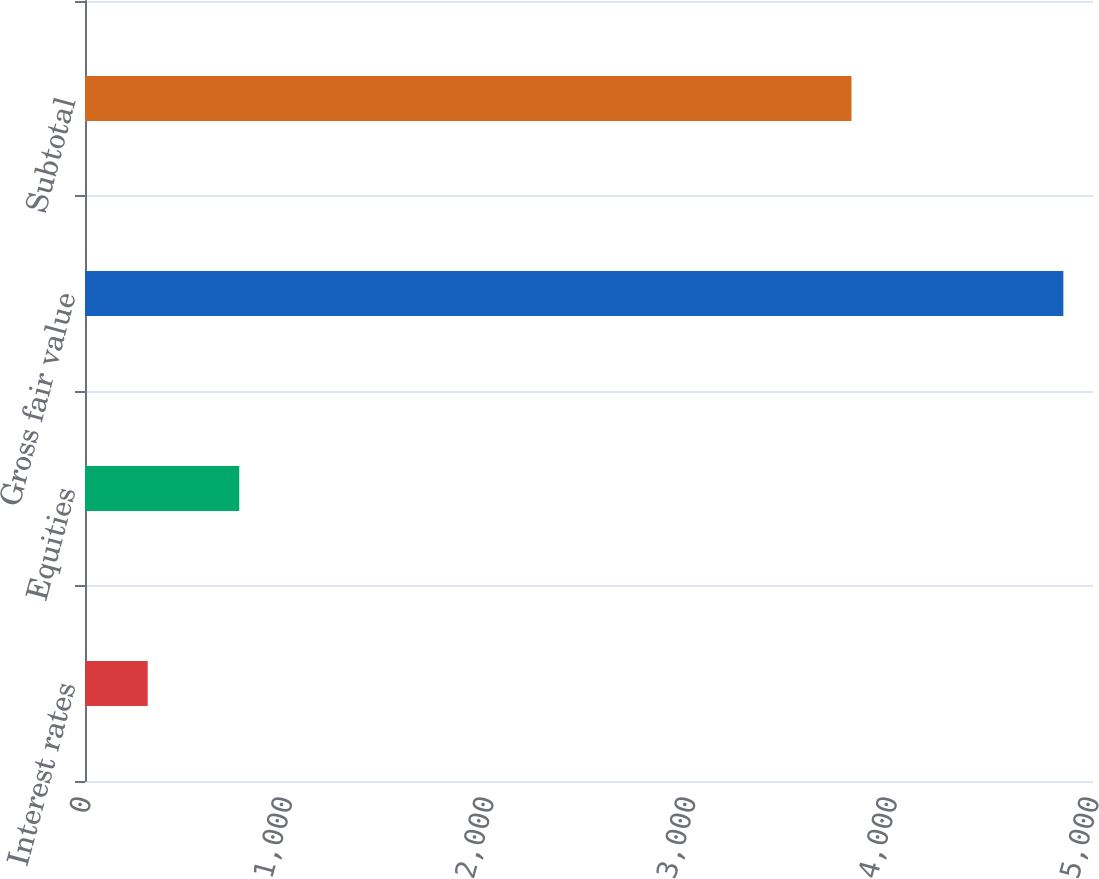Convert chart to OTSL. <chart><loc_0><loc_0><loc_500><loc_500><bar_chart><fcel>Interest rates<fcel>Equities<fcel>Gross fair value<fcel>Subtotal<nl><fcel>311<fcel>765.2<fcel>4853<fcel>3802<nl></chart> 